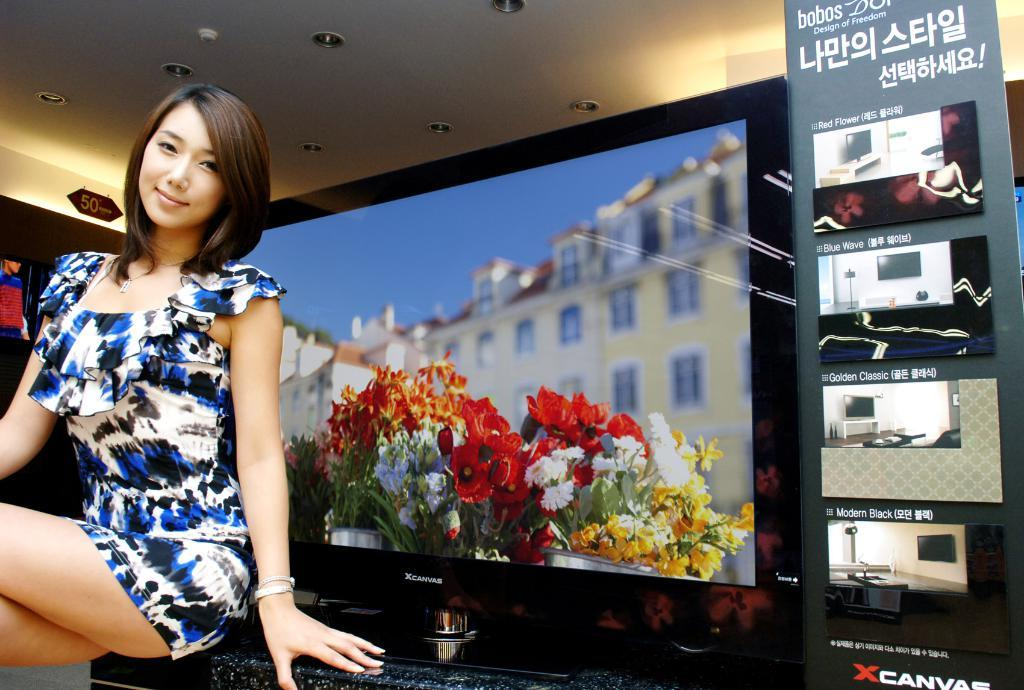<image>
Give a short and clear explanation of the subsequent image. A woman in a blue and white dress is posing in front of a xcanvas branded television. 